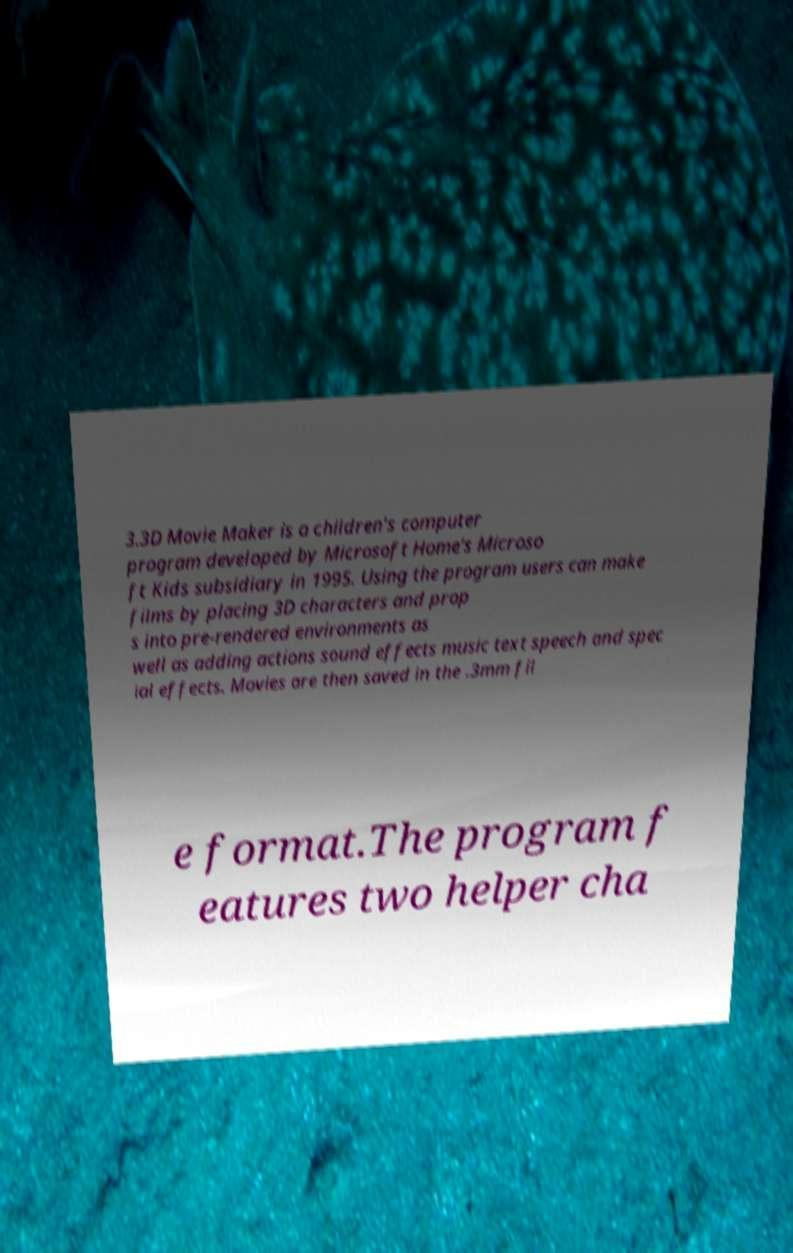For documentation purposes, I need the text within this image transcribed. Could you provide that? 3.3D Movie Maker is a children's computer program developed by Microsoft Home's Microso ft Kids subsidiary in 1995. Using the program users can make films by placing 3D characters and prop s into pre-rendered environments as well as adding actions sound effects music text speech and spec ial effects. Movies are then saved in the .3mm fil e format.The program f eatures two helper cha 